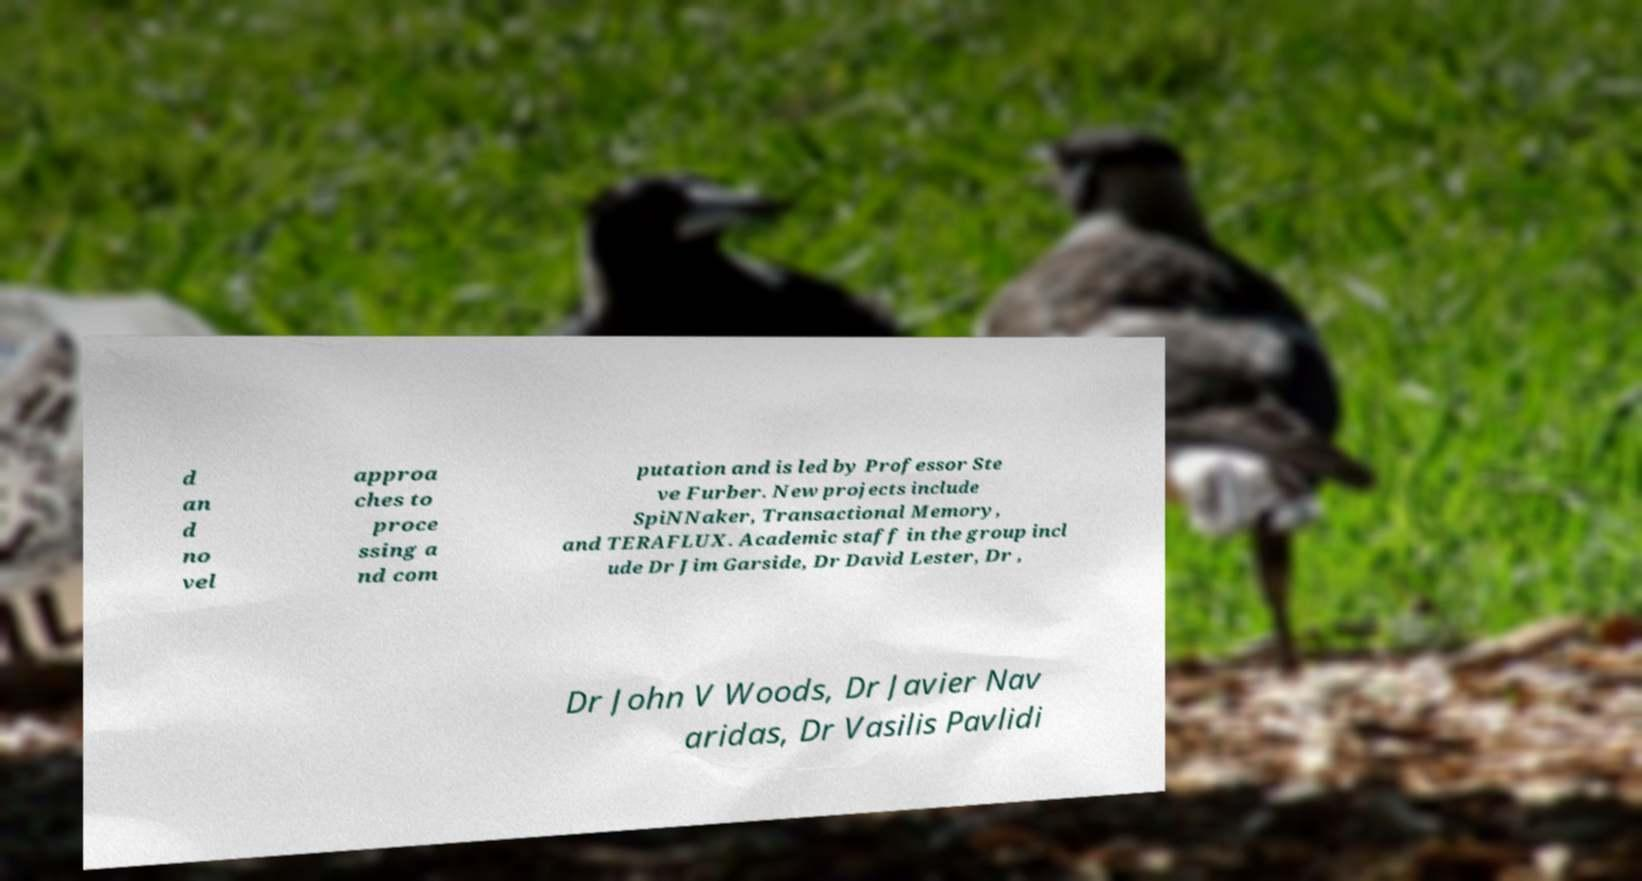For documentation purposes, I need the text within this image transcribed. Could you provide that? d an d no vel approa ches to proce ssing a nd com putation and is led by Professor Ste ve Furber. New projects include SpiNNaker, Transactional Memory, and TERAFLUX. Academic staff in the group incl ude Dr Jim Garside, Dr David Lester, Dr , Dr John V Woods, Dr Javier Nav aridas, Dr Vasilis Pavlidi 